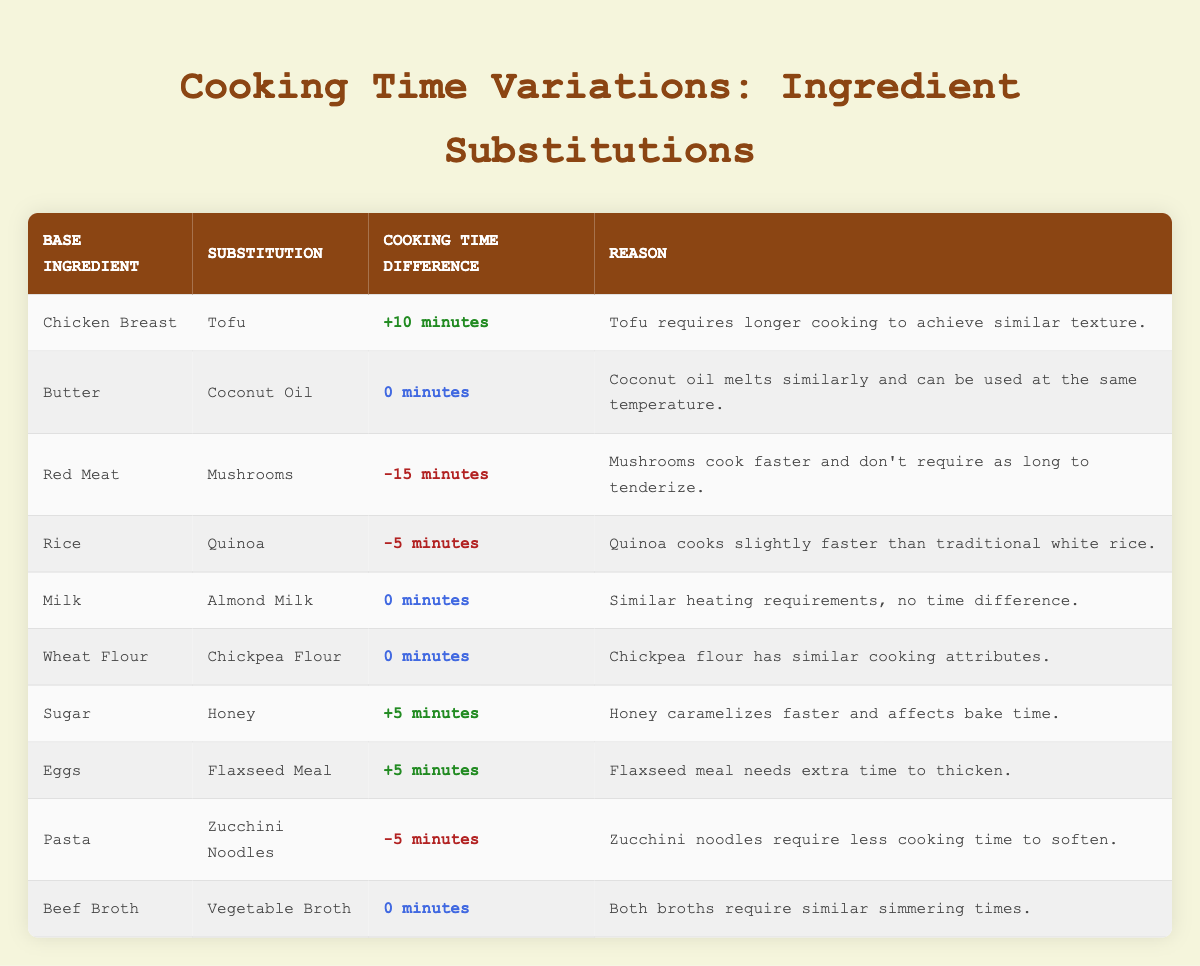What is the cooking time difference when substituting Chicken Breast with Tofu? The cooking time difference for this substitution is specifically mentioned in the table as "+10 minutes."
Answer: +10 minutes How much faster do Mushrooms cook compared to Red Meat? The table states that substituting Red Meat with Mushrooms results in a cooking time difference of "-15 minutes," which indicates that Mushrooms cook 15 minutes faster.
Answer: 15 minutes Is there any time difference when using Almond Milk instead of Milk? The table indicates that the cooking time difference for this substitution is "0 minutes," which means there is no time difference.
Answer: No What is the average cooking time difference for the following ingredients: Sugar to Honey and Eggs to Flaxseed Meal? The time differences for Sugar to Honey and Eggs to Flaxseed Meal are "+5 minutes" and "+5 minutes," respectively. Summing these gives 10 minutes. The average is 10/2 = 5 minutes.
Answer: 5 minutes If you substitute Pasta with Zucchini Noodles, how much cooking time does it save? The cooking time difference provided in the table shows that Zucchini Noodles require "-5 minutes" less cooking time than Pasta, indicating a time saving.
Answer: 5 minutes Do Tofu and Coconut Oil require different cooking times when used in a recipe? According to the table, Tofu requires an additional "+10 minutes" whereas Coconut Oil has "0 minutes," indicating that they do require different cooking times.
Answer: Yes What ingredients can be substituted without changing the cooking time at all? The table lists both Almond Milk and Milk, Wheat Flour and Chickpea Flour, as well as Butter and Coconut Oil, all of which have a cooking time difference of "0 minutes."
Answer: Almond Milk, Wheat Flour, Butter How much longer do you need to cook if you replace Eggs with Flaxseed Meal? The cooking time difference listed in the table for substituting Eggs with Flaxseed Meal is "+5 minutes," meaning you need to cook 5 minutes longer.
Answer: 5 minutes If someone wants to use Chickpea Flour instead of Wheat Flour, how does it affect the cooking time? The table indicates that substituting Chickpea Flour for Wheat Flour leads to a "0 minutes" difference in cooking time, implying no change needed.
Answer: No change 